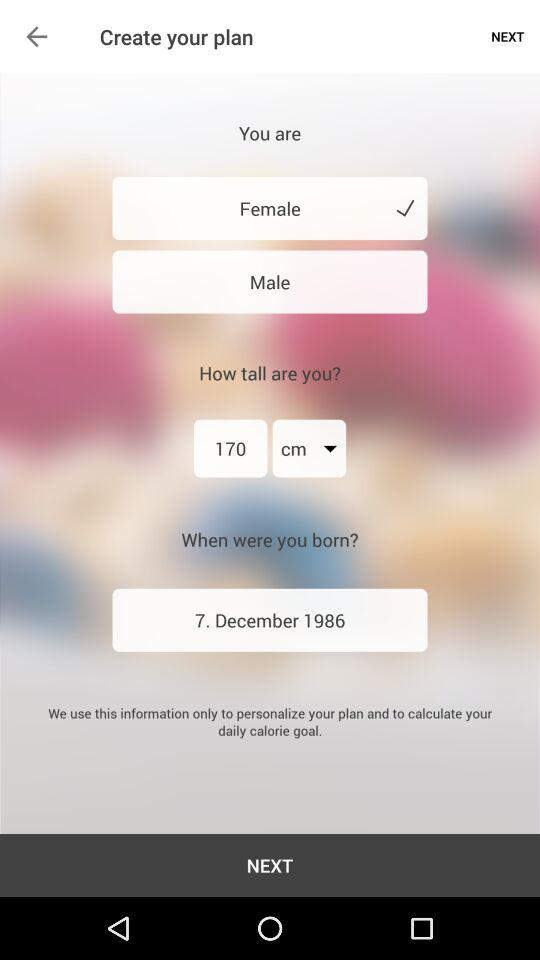What is the height of the user?
Answer the question using a single word or phrase. 170 cm 